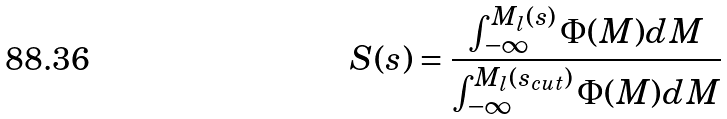Convert formula to latex. <formula><loc_0><loc_0><loc_500><loc_500>S ( s ) = \frac { \int _ { - \infty } ^ { M _ { l } ( s ) } \Phi ( M ) d M } { \int _ { - \infty } ^ { M _ { l } ( s _ { c u t } ) } \Phi ( M ) d M } \,</formula> 